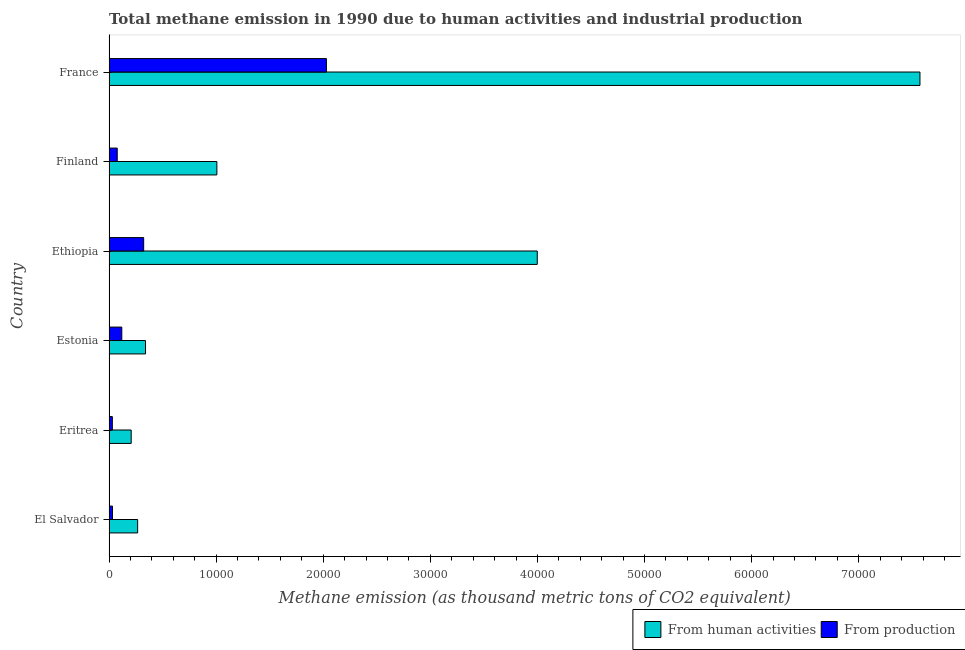Are the number of bars per tick equal to the number of legend labels?
Your answer should be compact. Yes. Are the number of bars on each tick of the Y-axis equal?
Provide a short and direct response. Yes. How many bars are there on the 2nd tick from the bottom?
Provide a short and direct response. 2. What is the label of the 6th group of bars from the top?
Your response must be concise. El Salvador. In how many cases, is the number of bars for a given country not equal to the number of legend labels?
Offer a very short reply. 0. What is the amount of emissions from human activities in Finland?
Offer a very short reply. 1.01e+04. Across all countries, what is the maximum amount of emissions generated from industries?
Keep it short and to the point. 2.03e+04. Across all countries, what is the minimum amount of emissions from human activities?
Give a very brief answer. 2070.6. In which country was the amount of emissions generated from industries maximum?
Your answer should be compact. France. In which country was the amount of emissions from human activities minimum?
Your answer should be very brief. Eritrea. What is the total amount of emissions generated from industries in the graph?
Keep it short and to the point. 2.61e+04. What is the difference between the amount of emissions generated from industries in Eritrea and that in Estonia?
Your answer should be compact. -882.3. What is the difference between the amount of emissions from human activities in Eritrea and the amount of emissions generated from industries in France?
Offer a very short reply. -1.82e+04. What is the average amount of emissions from human activities per country?
Provide a succinct answer. 2.23e+04. What is the difference between the amount of emissions generated from industries and amount of emissions from human activities in Ethiopia?
Your response must be concise. -3.67e+04. In how many countries, is the amount of emissions generated from industries greater than 26000 thousand metric tons?
Provide a short and direct response. 0. What is the ratio of the amount of emissions generated from industries in Eritrea to that in France?
Give a very brief answer. 0.01. Is the amount of emissions generated from industries in Ethiopia less than that in Finland?
Offer a terse response. No. Is the difference between the amount of emissions from human activities in Ethiopia and Finland greater than the difference between the amount of emissions generated from industries in Ethiopia and Finland?
Make the answer very short. Yes. What is the difference between the highest and the second highest amount of emissions from human activities?
Your answer should be compact. 3.57e+04. What is the difference between the highest and the lowest amount of emissions from human activities?
Offer a terse response. 7.36e+04. In how many countries, is the amount of emissions generated from industries greater than the average amount of emissions generated from industries taken over all countries?
Provide a short and direct response. 1. Is the sum of the amount of emissions from human activities in El Salvador and Estonia greater than the maximum amount of emissions generated from industries across all countries?
Offer a terse response. No. What does the 1st bar from the top in Eritrea represents?
Give a very brief answer. From production. What does the 2nd bar from the bottom in Estonia represents?
Keep it short and to the point. From production. What is the difference between two consecutive major ticks on the X-axis?
Offer a terse response. 10000. Are the values on the major ticks of X-axis written in scientific E-notation?
Make the answer very short. No. Where does the legend appear in the graph?
Offer a very short reply. Bottom right. How are the legend labels stacked?
Ensure brevity in your answer.  Horizontal. What is the title of the graph?
Make the answer very short. Total methane emission in 1990 due to human activities and industrial production. Does "Formally registered" appear as one of the legend labels in the graph?
Keep it short and to the point. No. What is the label or title of the X-axis?
Your answer should be very brief. Methane emission (as thousand metric tons of CO2 equivalent). What is the Methane emission (as thousand metric tons of CO2 equivalent) of From human activities in El Salvador?
Offer a terse response. 2672.9. What is the Methane emission (as thousand metric tons of CO2 equivalent) of From production in El Salvador?
Offer a very short reply. 325.8. What is the Methane emission (as thousand metric tons of CO2 equivalent) of From human activities in Eritrea?
Make the answer very short. 2070.6. What is the Methane emission (as thousand metric tons of CO2 equivalent) in From production in Eritrea?
Offer a terse response. 310.4. What is the Methane emission (as thousand metric tons of CO2 equivalent) of From human activities in Estonia?
Your response must be concise. 3408.3. What is the Methane emission (as thousand metric tons of CO2 equivalent) of From production in Estonia?
Provide a short and direct response. 1192.7. What is the Methane emission (as thousand metric tons of CO2 equivalent) in From human activities in Ethiopia?
Offer a terse response. 4.00e+04. What is the Methane emission (as thousand metric tons of CO2 equivalent) in From production in Ethiopia?
Your response must be concise. 3236. What is the Methane emission (as thousand metric tons of CO2 equivalent) of From human activities in Finland?
Your answer should be compact. 1.01e+04. What is the Methane emission (as thousand metric tons of CO2 equivalent) in From production in Finland?
Ensure brevity in your answer.  767.5. What is the Methane emission (as thousand metric tons of CO2 equivalent) in From human activities in France?
Offer a terse response. 7.57e+04. What is the Methane emission (as thousand metric tons of CO2 equivalent) in From production in France?
Ensure brevity in your answer.  2.03e+04. Across all countries, what is the maximum Methane emission (as thousand metric tons of CO2 equivalent) of From human activities?
Keep it short and to the point. 7.57e+04. Across all countries, what is the maximum Methane emission (as thousand metric tons of CO2 equivalent) in From production?
Ensure brevity in your answer.  2.03e+04. Across all countries, what is the minimum Methane emission (as thousand metric tons of CO2 equivalent) of From human activities?
Ensure brevity in your answer.  2070.6. Across all countries, what is the minimum Methane emission (as thousand metric tons of CO2 equivalent) of From production?
Your answer should be very brief. 310.4. What is the total Methane emission (as thousand metric tons of CO2 equivalent) in From human activities in the graph?
Your answer should be very brief. 1.34e+05. What is the total Methane emission (as thousand metric tons of CO2 equivalent) in From production in the graph?
Your answer should be very brief. 2.61e+04. What is the difference between the Methane emission (as thousand metric tons of CO2 equivalent) of From human activities in El Salvador and that in Eritrea?
Your answer should be very brief. 602.3. What is the difference between the Methane emission (as thousand metric tons of CO2 equivalent) in From production in El Salvador and that in Eritrea?
Your response must be concise. 15.4. What is the difference between the Methane emission (as thousand metric tons of CO2 equivalent) of From human activities in El Salvador and that in Estonia?
Make the answer very short. -735.4. What is the difference between the Methane emission (as thousand metric tons of CO2 equivalent) in From production in El Salvador and that in Estonia?
Make the answer very short. -866.9. What is the difference between the Methane emission (as thousand metric tons of CO2 equivalent) of From human activities in El Salvador and that in Ethiopia?
Give a very brief answer. -3.73e+04. What is the difference between the Methane emission (as thousand metric tons of CO2 equivalent) of From production in El Salvador and that in Ethiopia?
Your answer should be compact. -2910.2. What is the difference between the Methane emission (as thousand metric tons of CO2 equivalent) of From human activities in El Salvador and that in Finland?
Your answer should be very brief. -7397.3. What is the difference between the Methane emission (as thousand metric tons of CO2 equivalent) in From production in El Salvador and that in Finland?
Offer a very short reply. -441.7. What is the difference between the Methane emission (as thousand metric tons of CO2 equivalent) of From human activities in El Salvador and that in France?
Provide a short and direct response. -7.30e+04. What is the difference between the Methane emission (as thousand metric tons of CO2 equivalent) in From production in El Salvador and that in France?
Provide a short and direct response. -2.00e+04. What is the difference between the Methane emission (as thousand metric tons of CO2 equivalent) of From human activities in Eritrea and that in Estonia?
Provide a succinct answer. -1337.7. What is the difference between the Methane emission (as thousand metric tons of CO2 equivalent) in From production in Eritrea and that in Estonia?
Keep it short and to the point. -882.3. What is the difference between the Methane emission (as thousand metric tons of CO2 equivalent) in From human activities in Eritrea and that in Ethiopia?
Offer a very short reply. -3.79e+04. What is the difference between the Methane emission (as thousand metric tons of CO2 equivalent) in From production in Eritrea and that in Ethiopia?
Your answer should be compact. -2925.6. What is the difference between the Methane emission (as thousand metric tons of CO2 equivalent) of From human activities in Eritrea and that in Finland?
Offer a very short reply. -7999.6. What is the difference between the Methane emission (as thousand metric tons of CO2 equivalent) of From production in Eritrea and that in Finland?
Give a very brief answer. -457.1. What is the difference between the Methane emission (as thousand metric tons of CO2 equivalent) in From human activities in Eritrea and that in France?
Keep it short and to the point. -7.36e+04. What is the difference between the Methane emission (as thousand metric tons of CO2 equivalent) in From production in Eritrea and that in France?
Provide a short and direct response. -2.00e+04. What is the difference between the Methane emission (as thousand metric tons of CO2 equivalent) of From human activities in Estonia and that in Ethiopia?
Provide a short and direct response. -3.66e+04. What is the difference between the Methane emission (as thousand metric tons of CO2 equivalent) of From production in Estonia and that in Ethiopia?
Your answer should be compact. -2043.3. What is the difference between the Methane emission (as thousand metric tons of CO2 equivalent) in From human activities in Estonia and that in Finland?
Ensure brevity in your answer.  -6661.9. What is the difference between the Methane emission (as thousand metric tons of CO2 equivalent) of From production in Estonia and that in Finland?
Your answer should be compact. 425.2. What is the difference between the Methane emission (as thousand metric tons of CO2 equivalent) of From human activities in Estonia and that in France?
Give a very brief answer. -7.23e+04. What is the difference between the Methane emission (as thousand metric tons of CO2 equivalent) in From production in Estonia and that in France?
Keep it short and to the point. -1.91e+04. What is the difference between the Methane emission (as thousand metric tons of CO2 equivalent) of From human activities in Ethiopia and that in Finland?
Offer a terse response. 2.99e+04. What is the difference between the Methane emission (as thousand metric tons of CO2 equivalent) in From production in Ethiopia and that in Finland?
Provide a succinct answer. 2468.5. What is the difference between the Methane emission (as thousand metric tons of CO2 equivalent) in From human activities in Ethiopia and that in France?
Your answer should be very brief. -3.57e+04. What is the difference between the Methane emission (as thousand metric tons of CO2 equivalent) of From production in Ethiopia and that in France?
Offer a very short reply. -1.71e+04. What is the difference between the Methane emission (as thousand metric tons of CO2 equivalent) of From human activities in Finland and that in France?
Your answer should be very brief. -6.56e+04. What is the difference between the Methane emission (as thousand metric tons of CO2 equivalent) in From production in Finland and that in France?
Your answer should be compact. -1.95e+04. What is the difference between the Methane emission (as thousand metric tons of CO2 equivalent) of From human activities in El Salvador and the Methane emission (as thousand metric tons of CO2 equivalent) of From production in Eritrea?
Offer a very short reply. 2362.5. What is the difference between the Methane emission (as thousand metric tons of CO2 equivalent) of From human activities in El Salvador and the Methane emission (as thousand metric tons of CO2 equivalent) of From production in Estonia?
Provide a short and direct response. 1480.2. What is the difference between the Methane emission (as thousand metric tons of CO2 equivalent) in From human activities in El Salvador and the Methane emission (as thousand metric tons of CO2 equivalent) in From production in Ethiopia?
Provide a succinct answer. -563.1. What is the difference between the Methane emission (as thousand metric tons of CO2 equivalent) of From human activities in El Salvador and the Methane emission (as thousand metric tons of CO2 equivalent) of From production in Finland?
Your answer should be very brief. 1905.4. What is the difference between the Methane emission (as thousand metric tons of CO2 equivalent) of From human activities in El Salvador and the Methane emission (as thousand metric tons of CO2 equivalent) of From production in France?
Provide a succinct answer. -1.76e+04. What is the difference between the Methane emission (as thousand metric tons of CO2 equivalent) of From human activities in Eritrea and the Methane emission (as thousand metric tons of CO2 equivalent) of From production in Estonia?
Keep it short and to the point. 877.9. What is the difference between the Methane emission (as thousand metric tons of CO2 equivalent) of From human activities in Eritrea and the Methane emission (as thousand metric tons of CO2 equivalent) of From production in Ethiopia?
Your response must be concise. -1165.4. What is the difference between the Methane emission (as thousand metric tons of CO2 equivalent) in From human activities in Eritrea and the Methane emission (as thousand metric tons of CO2 equivalent) in From production in Finland?
Ensure brevity in your answer.  1303.1. What is the difference between the Methane emission (as thousand metric tons of CO2 equivalent) in From human activities in Eritrea and the Methane emission (as thousand metric tons of CO2 equivalent) in From production in France?
Give a very brief answer. -1.82e+04. What is the difference between the Methane emission (as thousand metric tons of CO2 equivalent) in From human activities in Estonia and the Methane emission (as thousand metric tons of CO2 equivalent) in From production in Ethiopia?
Make the answer very short. 172.3. What is the difference between the Methane emission (as thousand metric tons of CO2 equivalent) in From human activities in Estonia and the Methane emission (as thousand metric tons of CO2 equivalent) in From production in Finland?
Give a very brief answer. 2640.8. What is the difference between the Methane emission (as thousand metric tons of CO2 equivalent) of From human activities in Estonia and the Methane emission (as thousand metric tons of CO2 equivalent) of From production in France?
Your response must be concise. -1.69e+04. What is the difference between the Methane emission (as thousand metric tons of CO2 equivalent) in From human activities in Ethiopia and the Methane emission (as thousand metric tons of CO2 equivalent) in From production in Finland?
Your response must be concise. 3.92e+04. What is the difference between the Methane emission (as thousand metric tons of CO2 equivalent) in From human activities in Ethiopia and the Methane emission (as thousand metric tons of CO2 equivalent) in From production in France?
Keep it short and to the point. 1.97e+04. What is the difference between the Methane emission (as thousand metric tons of CO2 equivalent) in From human activities in Finland and the Methane emission (as thousand metric tons of CO2 equivalent) in From production in France?
Offer a very short reply. -1.02e+04. What is the average Methane emission (as thousand metric tons of CO2 equivalent) of From human activities per country?
Your response must be concise. 2.23e+04. What is the average Methane emission (as thousand metric tons of CO2 equivalent) in From production per country?
Provide a short and direct response. 4354.98. What is the difference between the Methane emission (as thousand metric tons of CO2 equivalent) of From human activities and Methane emission (as thousand metric tons of CO2 equivalent) of From production in El Salvador?
Give a very brief answer. 2347.1. What is the difference between the Methane emission (as thousand metric tons of CO2 equivalent) of From human activities and Methane emission (as thousand metric tons of CO2 equivalent) of From production in Eritrea?
Provide a short and direct response. 1760.2. What is the difference between the Methane emission (as thousand metric tons of CO2 equivalent) in From human activities and Methane emission (as thousand metric tons of CO2 equivalent) in From production in Estonia?
Keep it short and to the point. 2215.6. What is the difference between the Methane emission (as thousand metric tons of CO2 equivalent) of From human activities and Methane emission (as thousand metric tons of CO2 equivalent) of From production in Ethiopia?
Offer a terse response. 3.67e+04. What is the difference between the Methane emission (as thousand metric tons of CO2 equivalent) of From human activities and Methane emission (as thousand metric tons of CO2 equivalent) of From production in Finland?
Make the answer very short. 9302.7. What is the difference between the Methane emission (as thousand metric tons of CO2 equivalent) in From human activities and Methane emission (as thousand metric tons of CO2 equivalent) in From production in France?
Provide a short and direct response. 5.54e+04. What is the ratio of the Methane emission (as thousand metric tons of CO2 equivalent) of From human activities in El Salvador to that in Eritrea?
Make the answer very short. 1.29. What is the ratio of the Methane emission (as thousand metric tons of CO2 equivalent) in From production in El Salvador to that in Eritrea?
Your response must be concise. 1.05. What is the ratio of the Methane emission (as thousand metric tons of CO2 equivalent) in From human activities in El Salvador to that in Estonia?
Your answer should be compact. 0.78. What is the ratio of the Methane emission (as thousand metric tons of CO2 equivalent) in From production in El Salvador to that in Estonia?
Ensure brevity in your answer.  0.27. What is the ratio of the Methane emission (as thousand metric tons of CO2 equivalent) in From human activities in El Salvador to that in Ethiopia?
Provide a succinct answer. 0.07. What is the ratio of the Methane emission (as thousand metric tons of CO2 equivalent) of From production in El Salvador to that in Ethiopia?
Your response must be concise. 0.1. What is the ratio of the Methane emission (as thousand metric tons of CO2 equivalent) in From human activities in El Salvador to that in Finland?
Offer a terse response. 0.27. What is the ratio of the Methane emission (as thousand metric tons of CO2 equivalent) in From production in El Salvador to that in Finland?
Offer a very short reply. 0.42. What is the ratio of the Methane emission (as thousand metric tons of CO2 equivalent) in From human activities in El Salvador to that in France?
Provide a short and direct response. 0.04. What is the ratio of the Methane emission (as thousand metric tons of CO2 equivalent) of From production in El Salvador to that in France?
Offer a very short reply. 0.02. What is the ratio of the Methane emission (as thousand metric tons of CO2 equivalent) in From human activities in Eritrea to that in Estonia?
Ensure brevity in your answer.  0.61. What is the ratio of the Methane emission (as thousand metric tons of CO2 equivalent) of From production in Eritrea to that in Estonia?
Give a very brief answer. 0.26. What is the ratio of the Methane emission (as thousand metric tons of CO2 equivalent) of From human activities in Eritrea to that in Ethiopia?
Give a very brief answer. 0.05. What is the ratio of the Methane emission (as thousand metric tons of CO2 equivalent) of From production in Eritrea to that in Ethiopia?
Your answer should be compact. 0.1. What is the ratio of the Methane emission (as thousand metric tons of CO2 equivalent) in From human activities in Eritrea to that in Finland?
Provide a succinct answer. 0.21. What is the ratio of the Methane emission (as thousand metric tons of CO2 equivalent) in From production in Eritrea to that in Finland?
Keep it short and to the point. 0.4. What is the ratio of the Methane emission (as thousand metric tons of CO2 equivalent) of From human activities in Eritrea to that in France?
Your response must be concise. 0.03. What is the ratio of the Methane emission (as thousand metric tons of CO2 equivalent) of From production in Eritrea to that in France?
Your answer should be compact. 0.02. What is the ratio of the Methane emission (as thousand metric tons of CO2 equivalent) in From human activities in Estonia to that in Ethiopia?
Offer a terse response. 0.09. What is the ratio of the Methane emission (as thousand metric tons of CO2 equivalent) of From production in Estonia to that in Ethiopia?
Your answer should be compact. 0.37. What is the ratio of the Methane emission (as thousand metric tons of CO2 equivalent) of From human activities in Estonia to that in Finland?
Your answer should be very brief. 0.34. What is the ratio of the Methane emission (as thousand metric tons of CO2 equivalent) of From production in Estonia to that in Finland?
Offer a very short reply. 1.55. What is the ratio of the Methane emission (as thousand metric tons of CO2 equivalent) of From human activities in Estonia to that in France?
Make the answer very short. 0.04. What is the ratio of the Methane emission (as thousand metric tons of CO2 equivalent) of From production in Estonia to that in France?
Keep it short and to the point. 0.06. What is the ratio of the Methane emission (as thousand metric tons of CO2 equivalent) of From human activities in Ethiopia to that in Finland?
Make the answer very short. 3.97. What is the ratio of the Methane emission (as thousand metric tons of CO2 equivalent) in From production in Ethiopia to that in Finland?
Your answer should be compact. 4.22. What is the ratio of the Methane emission (as thousand metric tons of CO2 equivalent) of From human activities in Ethiopia to that in France?
Keep it short and to the point. 0.53. What is the ratio of the Methane emission (as thousand metric tons of CO2 equivalent) of From production in Ethiopia to that in France?
Keep it short and to the point. 0.16. What is the ratio of the Methane emission (as thousand metric tons of CO2 equivalent) of From human activities in Finland to that in France?
Make the answer very short. 0.13. What is the ratio of the Methane emission (as thousand metric tons of CO2 equivalent) in From production in Finland to that in France?
Provide a short and direct response. 0.04. What is the difference between the highest and the second highest Methane emission (as thousand metric tons of CO2 equivalent) of From human activities?
Make the answer very short. 3.57e+04. What is the difference between the highest and the second highest Methane emission (as thousand metric tons of CO2 equivalent) of From production?
Ensure brevity in your answer.  1.71e+04. What is the difference between the highest and the lowest Methane emission (as thousand metric tons of CO2 equivalent) in From human activities?
Offer a very short reply. 7.36e+04. What is the difference between the highest and the lowest Methane emission (as thousand metric tons of CO2 equivalent) in From production?
Give a very brief answer. 2.00e+04. 